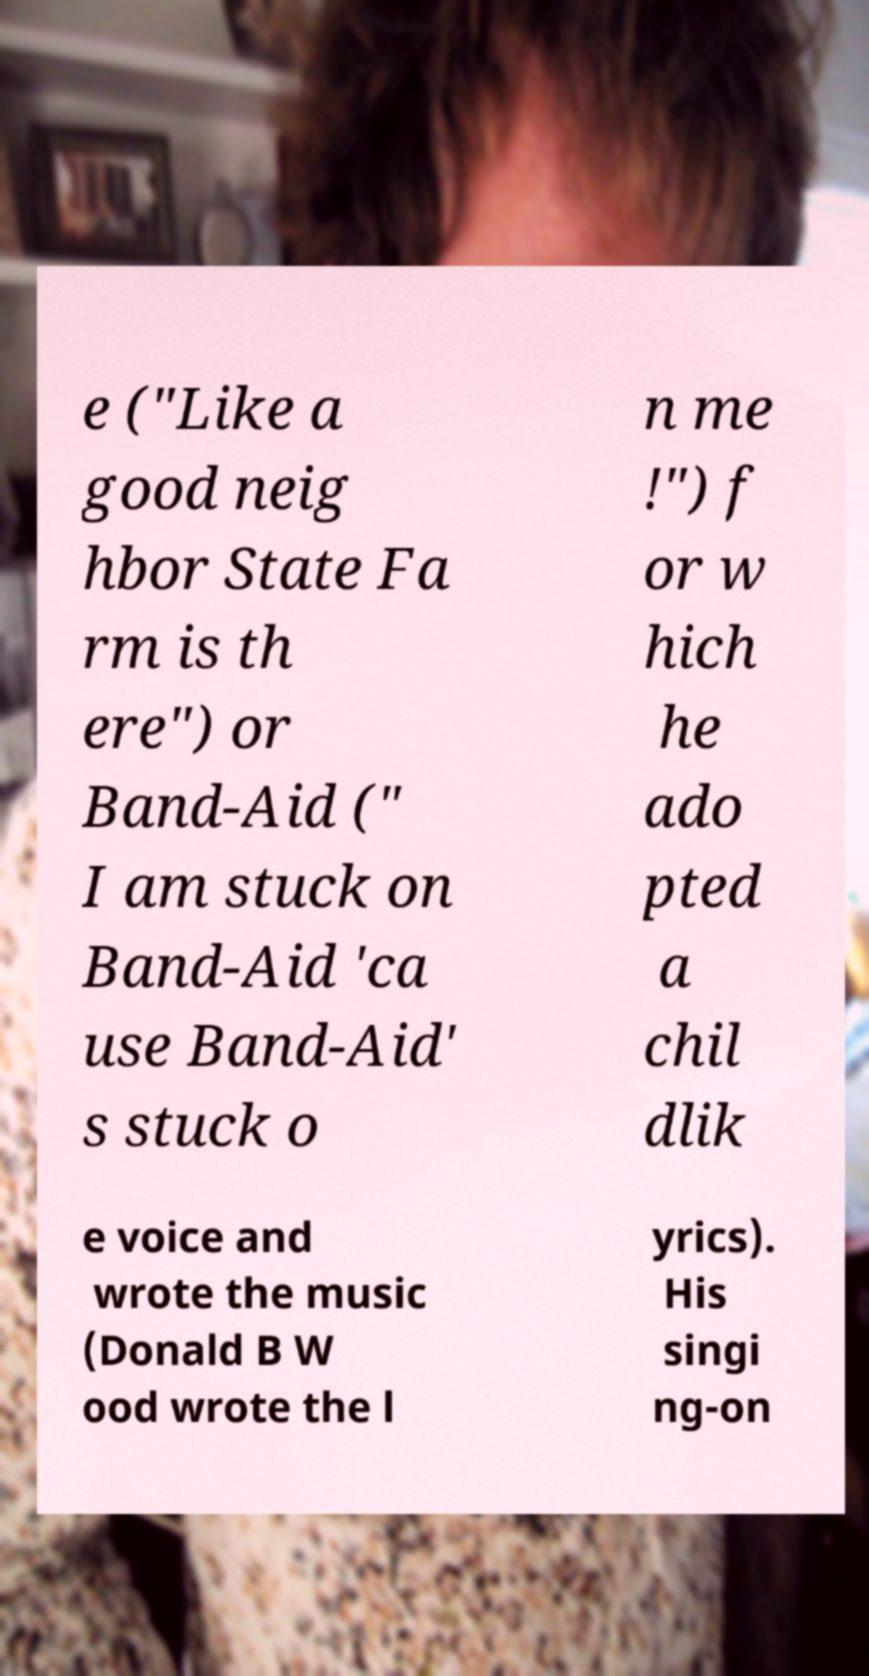Please identify and transcribe the text found in this image. e ("Like a good neig hbor State Fa rm is th ere") or Band-Aid (" I am stuck on Band-Aid 'ca use Band-Aid' s stuck o n me !") f or w hich he ado pted a chil dlik e voice and wrote the music (Donald B W ood wrote the l yrics). His singi ng-on 